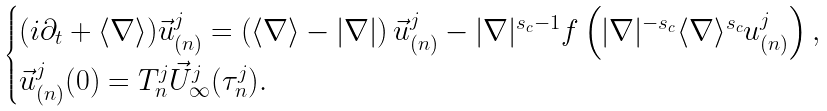Convert formula to latex. <formula><loc_0><loc_0><loc_500><loc_500>\begin{cases} ( i \partial _ { t } + \langle \nabla \rangle ) \vec { u } _ { ( n ) } ^ { j } = \left ( \langle \nabla \rangle - | \nabla | \right ) \vec { u } _ { ( n ) } ^ { j } - | \nabla | ^ { s _ { c } - 1 } f \left ( | \nabla | ^ { - s _ { c } } \langle \nabla \rangle ^ { s _ { c } } u _ { ( n ) } ^ { j } \right ) , \\ \vec { u } _ { ( n ) } ^ { j } ( 0 ) = T _ { n } ^ { j } \vec { U } _ { \infty } ^ { j } ( \tau _ { n } ^ { j } ) . \end{cases}</formula> 